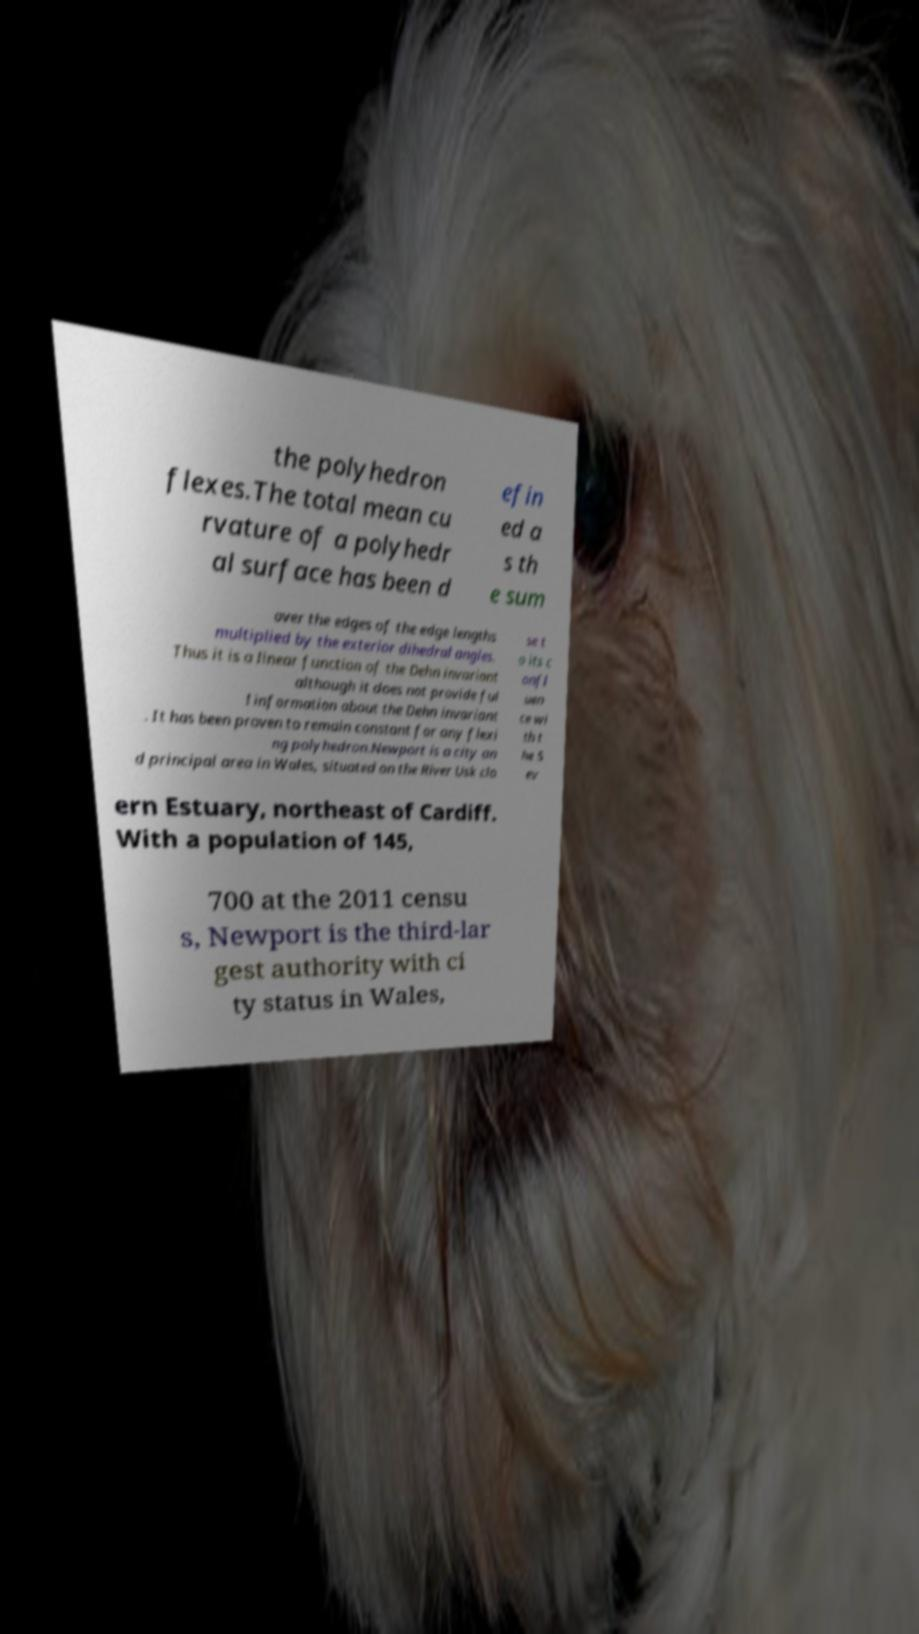I need the written content from this picture converted into text. Can you do that? the polyhedron flexes.The total mean cu rvature of a polyhedr al surface has been d efin ed a s th e sum over the edges of the edge lengths multiplied by the exterior dihedral angles. Thus it is a linear function of the Dehn invariant although it does not provide ful l information about the Dehn invariant . It has been proven to remain constant for any flexi ng polyhedron.Newport is a city an d principal area in Wales, situated on the River Usk clo se t o its c onfl uen ce wi th t he S ev ern Estuary, northeast of Cardiff. With a population of 145, 700 at the 2011 censu s, Newport is the third-lar gest authority with ci ty status in Wales, 